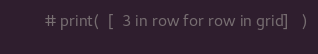Convert code to text. <code><loc_0><loc_0><loc_500><loc_500><_Python_>
        # print(  [  3 in row for row in grid]   )
        </code> 